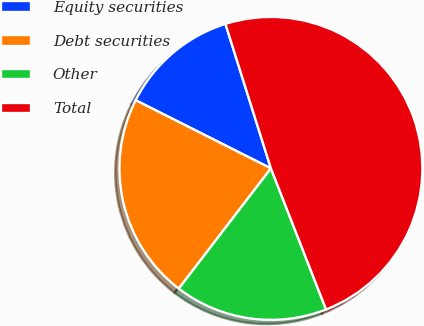Convert chart to OTSL. <chart><loc_0><loc_0><loc_500><loc_500><pie_chart><fcel>Equity securities<fcel>Debt securities<fcel>Other<fcel>Total<nl><fcel>12.72%<fcel>22.02%<fcel>16.34%<fcel>48.92%<nl></chart> 